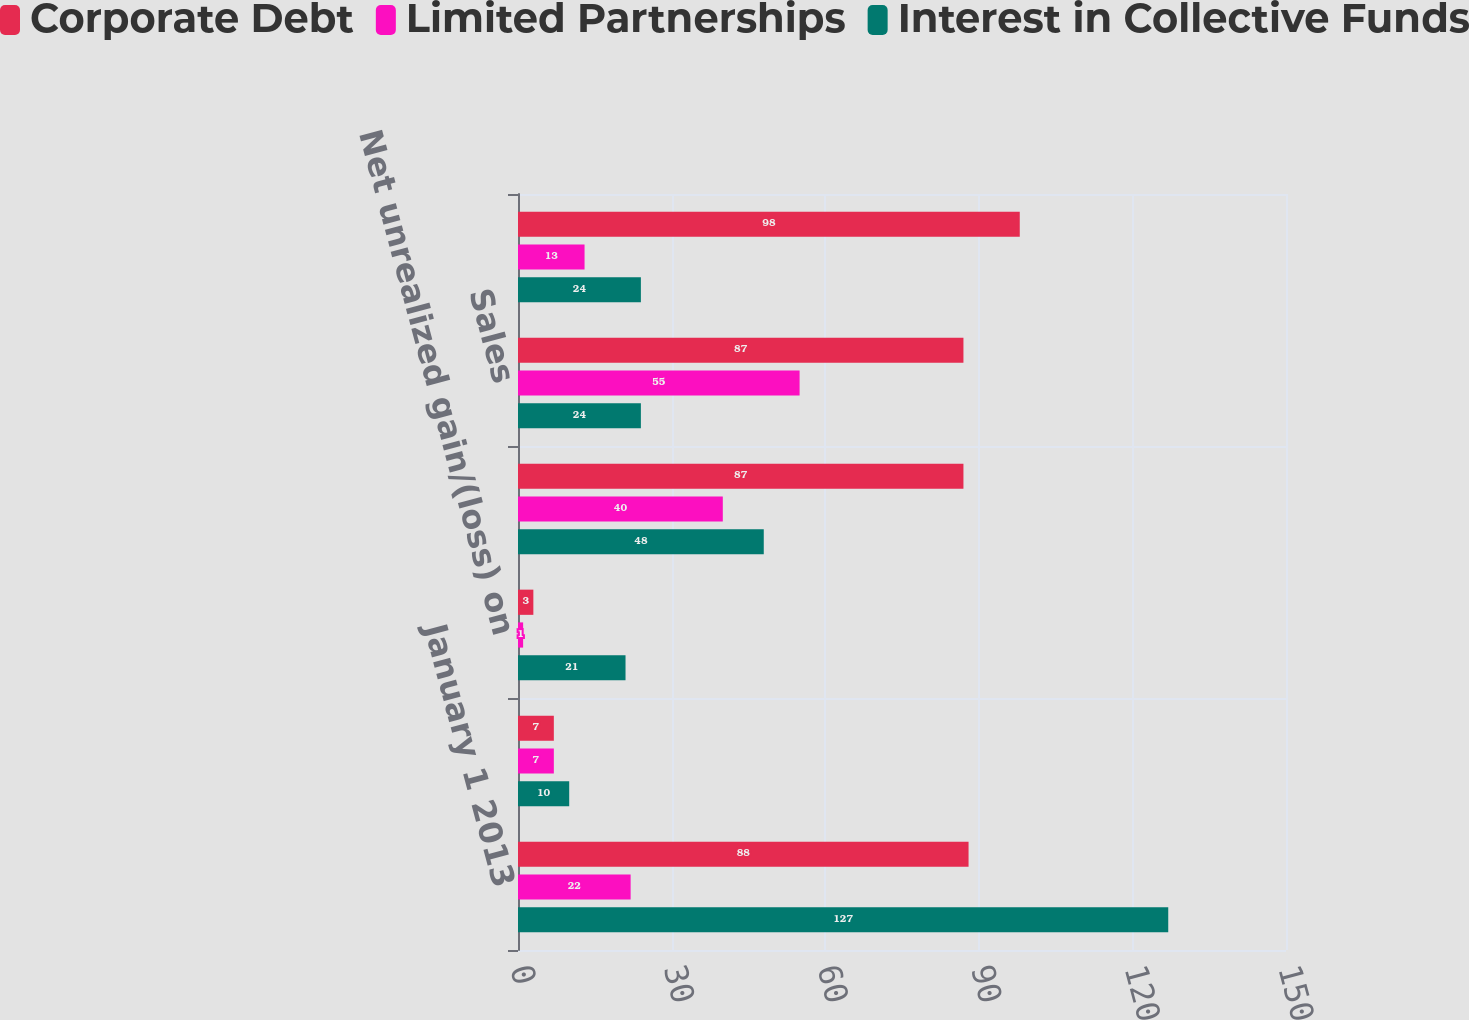Convert chart to OTSL. <chart><loc_0><loc_0><loc_500><loc_500><stacked_bar_chart><ecel><fcel>January 1 2013<fcel>Net realized gain/(loss) on<fcel>Net unrealized gain/(loss) on<fcel>Purchases<fcel>Sales<fcel>December 31 2013<nl><fcel>Corporate Debt<fcel>88<fcel>7<fcel>3<fcel>87<fcel>87<fcel>98<nl><fcel>Limited Partnerships<fcel>22<fcel>7<fcel>1<fcel>40<fcel>55<fcel>13<nl><fcel>Interest in Collective Funds<fcel>127<fcel>10<fcel>21<fcel>48<fcel>24<fcel>24<nl></chart> 